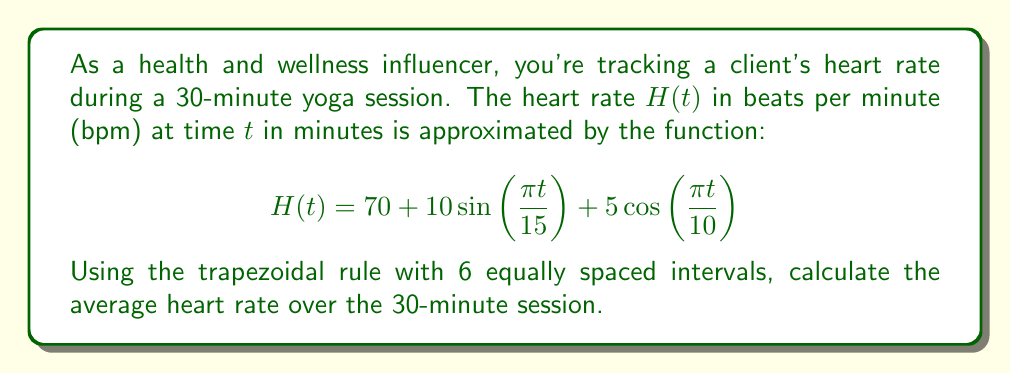Can you solve this math problem? To solve this problem, we'll use the trapezoidal rule for numerical integration and then divide by the time period to find the average.

1) The trapezoidal rule for n intervals is given by:

   $$\int_a^b f(x)dx \approx \frac{b-a}{2n}[f(a) + 2f(x_1) + 2f(x_2) + ... + 2f(x_{n-1}) + f(b)]$$

2) In our case, $a=0$, $b=30$, and $n=6$. The width of each interval is $\frac{30}{6} = 5$ minutes.

3) We need to evaluate $H(t)$ at $t = 0, 5, 10, 15, 20, 25, 30$:

   $H(0) = 70 + 10\sin(0) + 5\cos(0) = 75$
   $H(5) = 70 + 10\sin(\frac{\pi}{3}) + 5\cos(\frac{\pi}{2}) \approx 78.66$
   $H(10) = 70 + 10\sin(\frac{2\pi}{3}) + 5\cos(\pi) \approx 78.66$
   $H(15) = 70 + 10\sin(\pi) + 5\cos(\frac{3\pi}{2}) = 60$
   $H(20) = 70 + 10\sin(\frac{4\pi}{3}) + 5\cos(2\pi) \approx 61.34$
   $H(25) = 70 + 10\sin(\frac{5\pi}{3}) + 5\cos(\frac{5\pi}{2}) \approx 71.34$
   $H(30) = 70 + 10\sin(2\pi) + 5\cos(3\pi) = 65$

4) Applying the trapezoidal rule:

   $$\int_0^{30} H(t)dt \approx \frac{30}{12}[75 + 2(78.66 + 78.66 + 60 + 61.34 + 71.34) + 65]$$
   $$\approx 2.5[75 + 2(350) + 65] = 2.5[840] = 2100$$

5) The average heart rate is the integral divided by the time period:

   Average Heart Rate $= \frac{2100}{30} = 70$ bpm
Answer: The average heart rate over the 30-minute yoga session is approximately 70 beats per minute (bpm). 